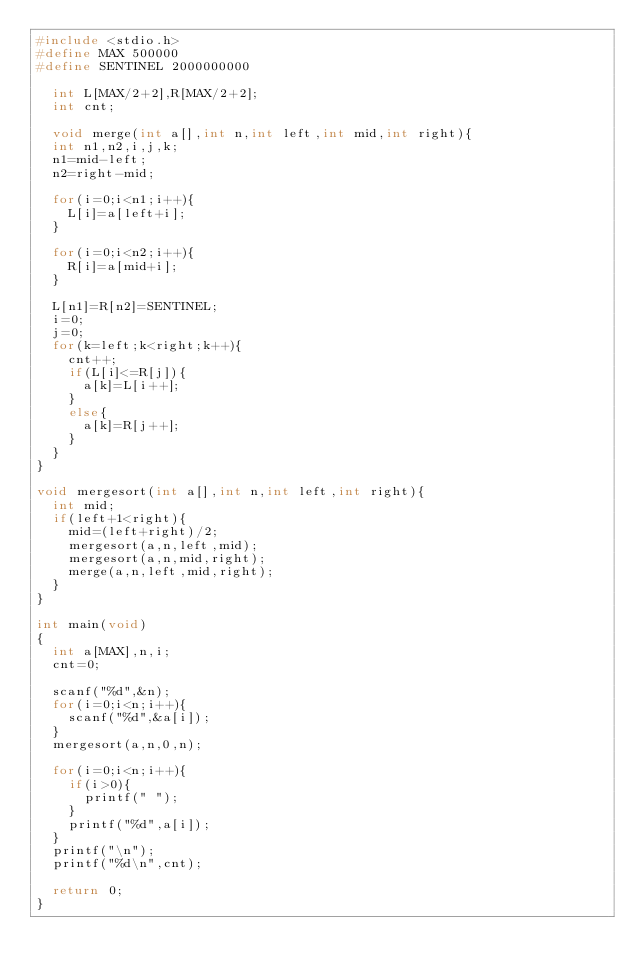Convert code to text. <code><loc_0><loc_0><loc_500><loc_500><_C_>#include <stdio.h>
#define MAX 500000
#define SENTINEL 2000000000

  int L[MAX/2+2],R[MAX/2+2];
  int cnt;

  void merge(int a[],int n,int left,int mid,int right){
  int n1,n2,i,j,k;
  n1=mid-left;
  n2=right-mid;

  for(i=0;i<n1;i++){
    L[i]=a[left+i];
  }

  for(i=0;i<n2;i++){
    R[i]=a[mid+i];
  }

  L[n1]=R[n2]=SENTINEL;
  i=0;
  j=0;
  for(k=left;k<right;k++){
    cnt++;
    if(L[i]<=R[j]){
      a[k]=L[i++];
    }
    else{
      a[k]=R[j++];
    }
  }
}

void mergesort(int a[],int n,int left,int right){
  int mid;
  if(left+1<right){
    mid=(left+right)/2;
    mergesort(a,n,left,mid);
    mergesort(a,n,mid,right);
    merge(a,n,left,mid,right);
  }
}

int main(void)
{
  int a[MAX],n,i;
  cnt=0;

  scanf("%d",&n);
  for(i=0;i<n;i++){
    scanf("%d",&a[i]);
  }
  mergesort(a,n,0,n);
  
  for(i=0;i<n;i++){
    if(i>0){
      printf(" ");
    }
    printf("%d",a[i]);
  }
  printf("\n");
  printf("%d\n",cnt);
  
  return 0;
}

</code> 